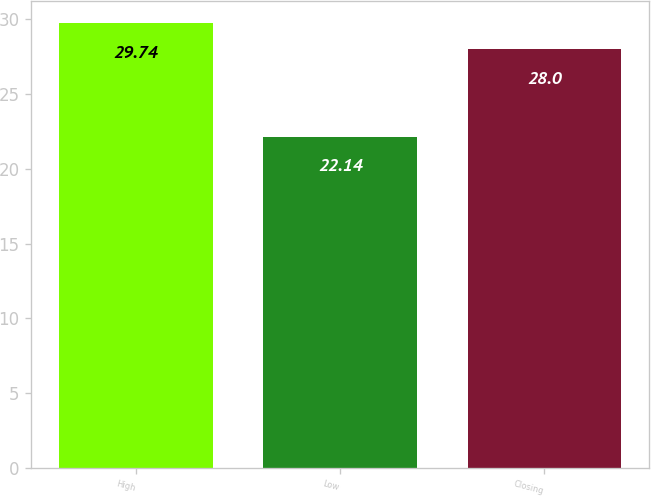Convert chart. <chart><loc_0><loc_0><loc_500><loc_500><bar_chart><fcel>High<fcel>Low<fcel>Closing<nl><fcel>29.74<fcel>22.14<fcel>28<nl></chart> 